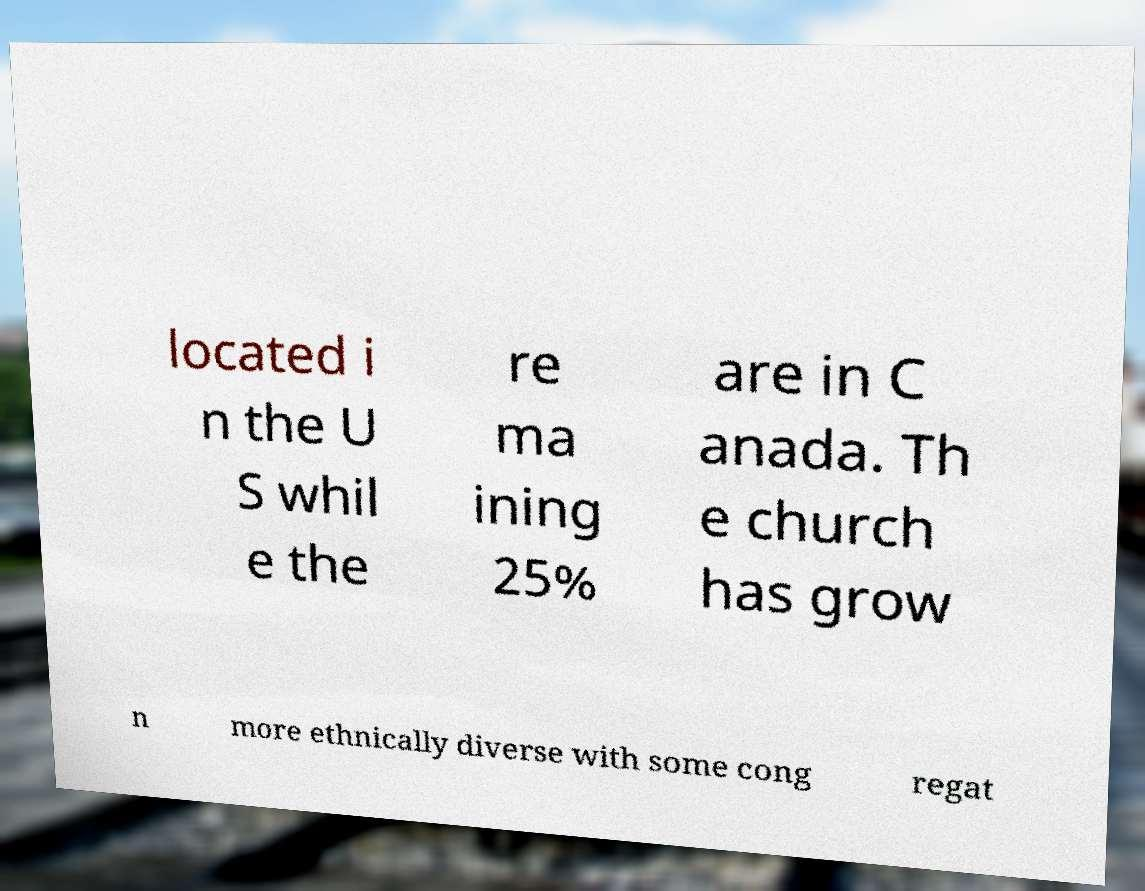Please read and relay the text visible in this image. What does it say? located i n the U S whil e the re ma ining 25% are in C anada. Th e church has grow n more ethnically diverse with some cong regat 